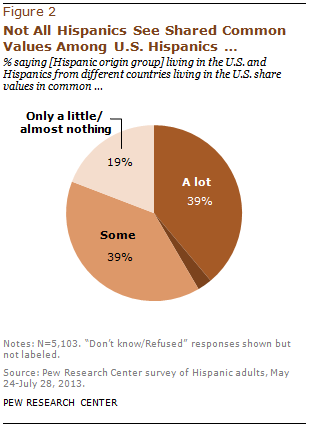Indicate a few pertinent items in this graphic. According to the data, a significant percentage of people chose only a little, with 19% of the respondents opting for this option. The top two options are the same value. 